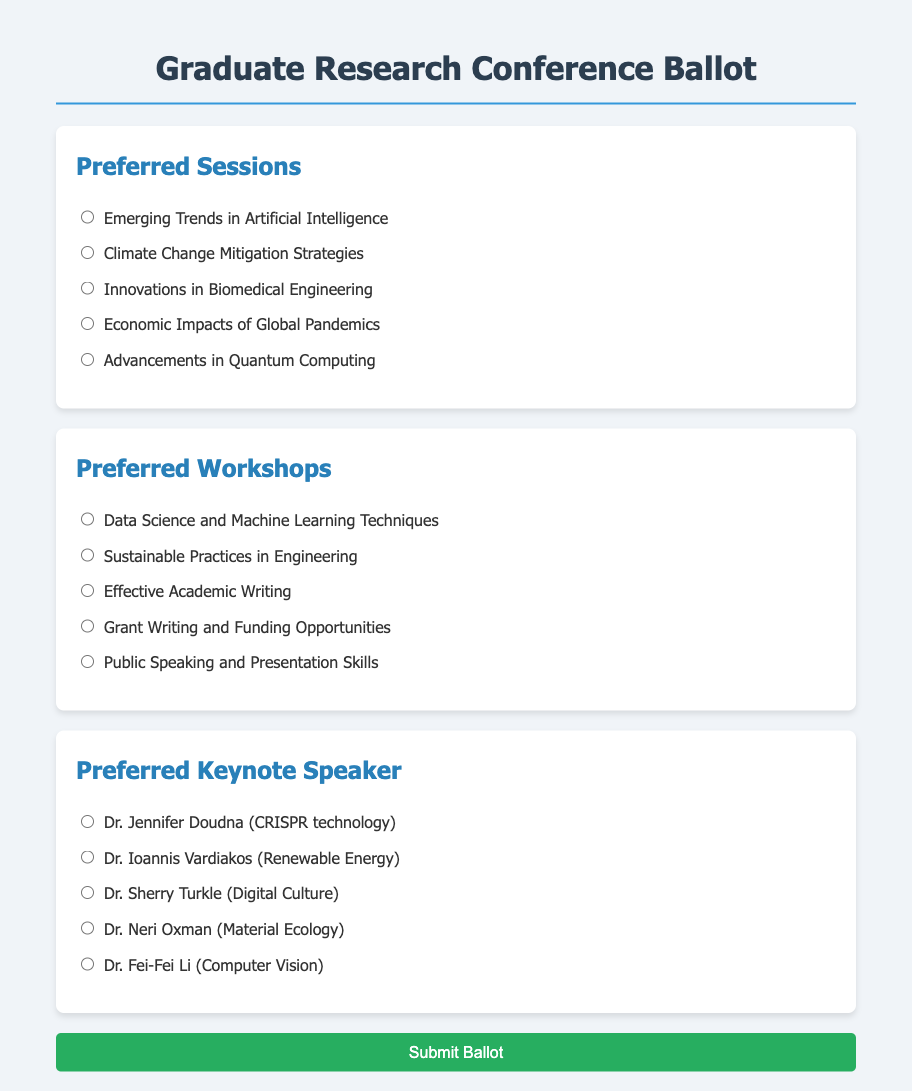what is the title of the document? The title of the document displayed at the top of the ballot is “Graduate Research Conference Ballot.”
Answer: Graduate Research Conference Ballot how many preferred sessions are listed? The document lists five different preferred sessions for attendees to choose from.
Answer: 5 who is the keynote speaker associated with CRISPR technology? The document details Dr. Jennifer Doudna as the keynote speaker related to CRISPR technology.
Answer: Dr. Jennifer Doudna what is one of the preferred workshops listed? The document provides several workshops, such as "Effective Academic Writing."
Answer: Effective Academic Writing which preferred session focuses on environmental issues? The session titled "Climate Change Mitigation Strategies" is focused on environmental issues.
Answer: Climate Change Mitigation Strategies how many total options are provided for keynote speakers? There are a total of five options listed for the preferred keynote speakers.
Answer: 5 which workshop addresses academic funding? The workshop titled "Grant Writing and Funding Opportunities" addresses academic funding.
Answer: Grant Writing and Funding Opportunities who is the keynote speaker known for work in Digital Culture? The document indicates Dr. Sherry Turkle as the speaker known for her work in Digital Culture.
Answer: Dr. Sherry Turkle 